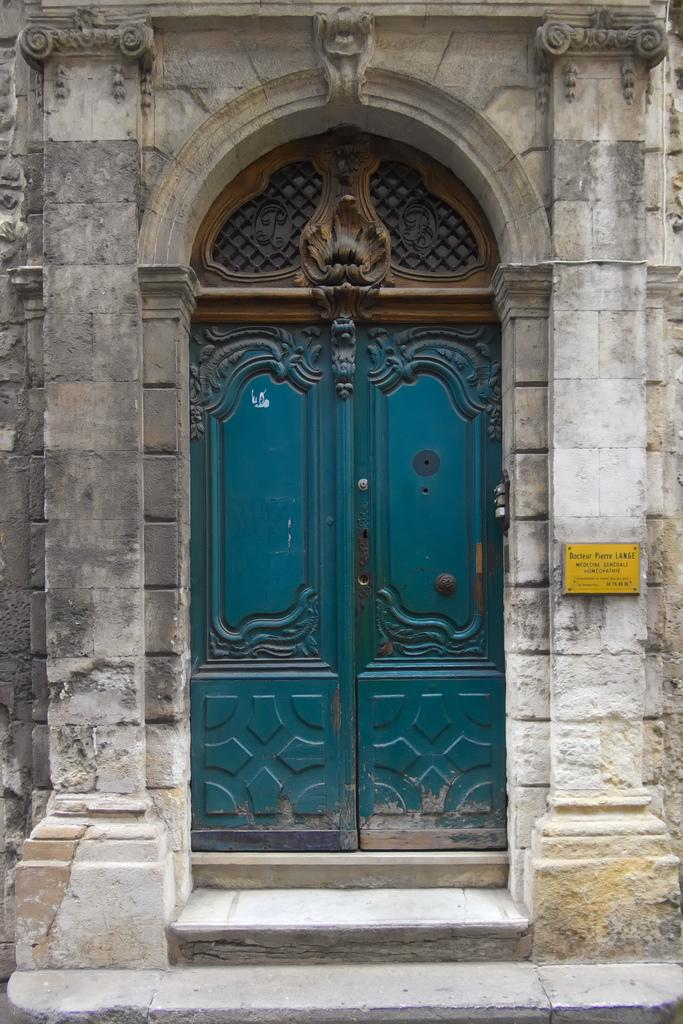What type of architectural feature can be seen in the image? There are doors in the image. What is attached to the wall in the image? There is a name board on the wall in the image. What type of secretary is sitting behind the doors in the image? There is no secretary present in the image; it only features doors and a name board on the wall. How many boys are visible in the image? There are no boys visible in the image. 